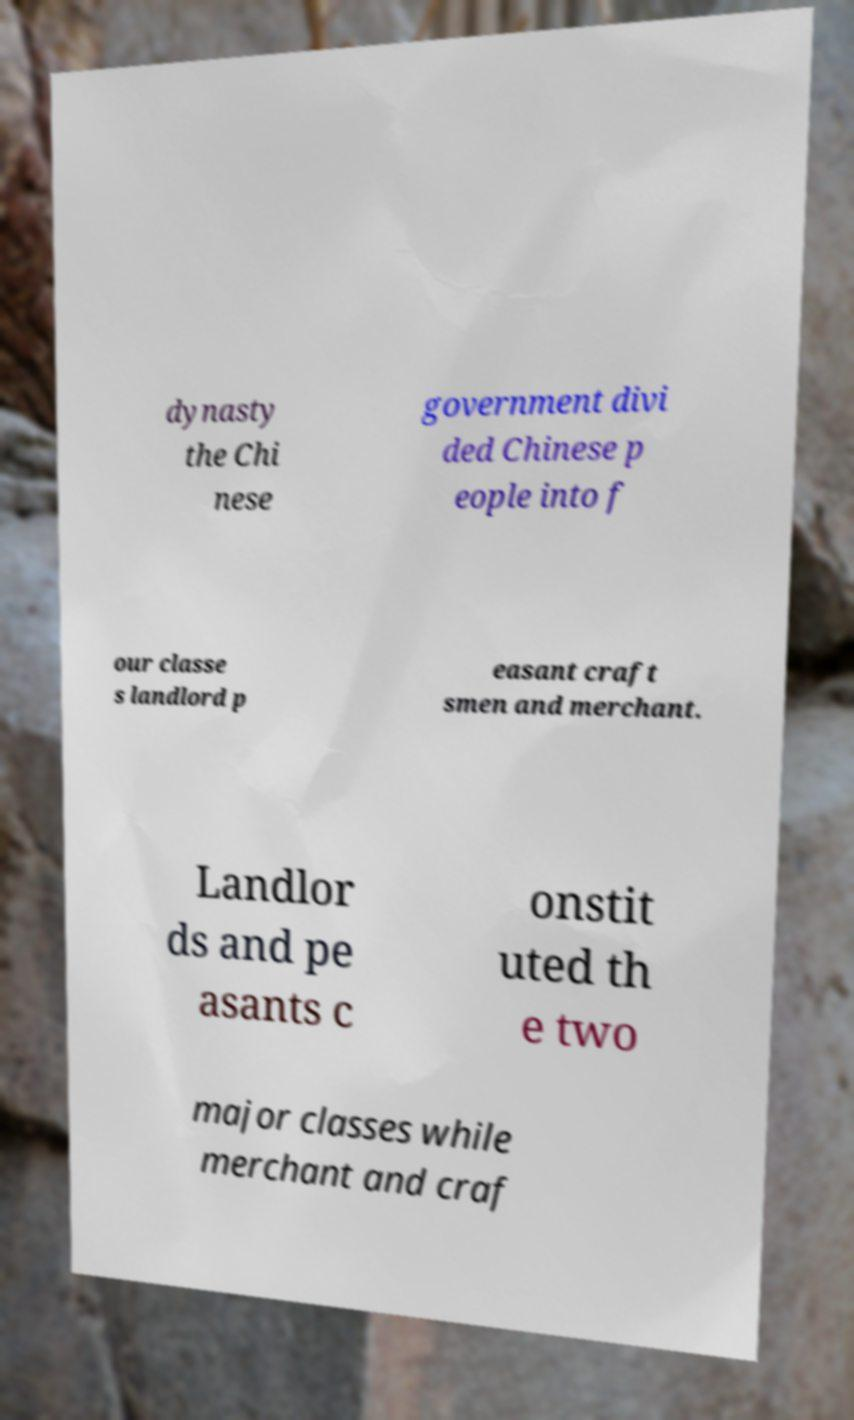Could you assist in decoding the text presented in this image and type it out clearly? dynasty the Chi nese government divi ded Chinese p eople into f our classe s landlord p easant craft smen and merchant. Landlor ds and pe asants c onstit uted th e two major classes while merchant and craf 